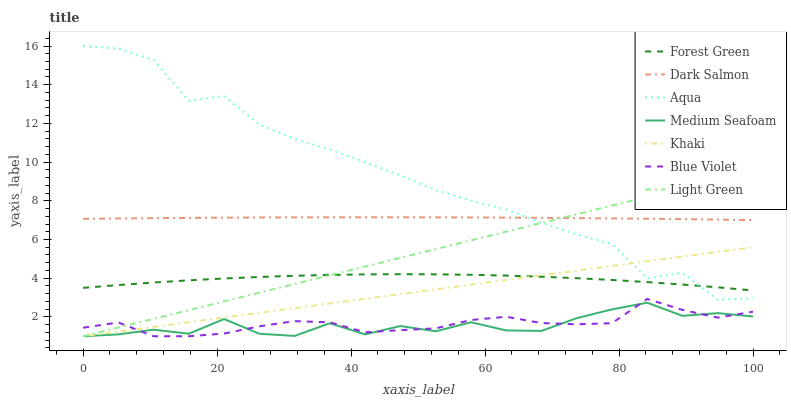Does Medium Seafoam have the minimum area under the curve?
Answer yes or no. Yes. Does Aqua have the maximum area under the curve?
Answer yes or no. Yes. Does Dark Salmon have the minimum area under the curve?
Answer yes or no. No. Does Dark Salmon have the maximum area under the curve?
Answer yes or no. No. Is Light Green the smoothest?
Answer yes or no. Yes. Is Aqua the roughest?
Answer yes or no. Yes. Is Dark Salmon the smoothest?
Answer yes or no. No. Is Dark Salmon the roughest?
Answer yes or no. No. Does Khaki have the lowest value?
Answer yes or no. Yes. Does Aqua have the lowest value?
Answer yes or no. No. Does Aqua have the highest value?
Answer yes or no. Yes. Does Dark Salmon have the highest value?
Answer yes or no. No. Is Khaki less than Dark Salmon?
Answer yes or no. Yes. Is Dark Salmon greater than Khaki?
Answer yes or no. Yes. Does Blue Violet intersect Light Green?
Answer yes or no. Yes. Is Blue Violet less than Light Green?
Answer yes or no. No. Is Blue Violet greater than Light Green?
Answer yes or no. No. Does Khaki intersect Dark Salmon?
Answer yes or no. No. 